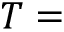Convert formula to latex. <formula><loc_0><loc_0><loc_500><loc_500>T =</formula> 